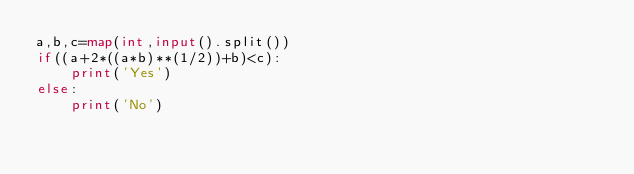<code> <loc_0><loc_0><loc_500><loc_500><_Python_>a,b,c=map(int,input().split())
if((a+2*((a*b)**(1/2))+b)<c):
    print('Yes')
else:
    print('No')</code> 